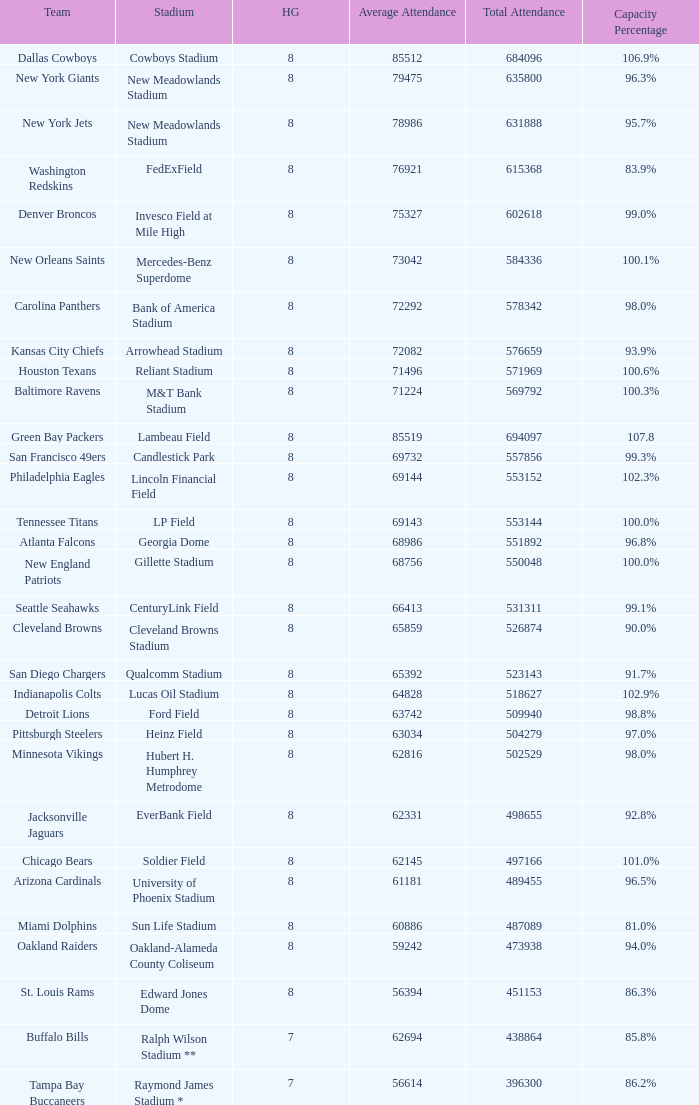Give me the full table as a dictionary. {'header': ['Team', 'Stadium', 'HG', 'Average Attendance', 'Total Attendance', 'Capacity Percentage'], 'rows': [['Dallas Cowboys', 'Cowboys Stadium', '8', '85512', '684096', '106.9%'], ['New York Giants', 'New Meadowlands Stadium', '8', '79475', '635800', '96.3%'], ['New York Jets', 'New Meadowlands Stadium', '8', '78986', '631888', '95.7%'], ['Washington Redskins', 'FedExField', '8', '76921', '615368', '83.9%'], ['Denver Broncos', 'Invesco Field at Mile High', '8', '75327', '602618', '99.0%'], ['New Orleans Saints', 'Mercedes-Benz Superdome', '8', '73042', '584336', '100.1%'], ['Carolina Panthers', 'Bank of America Stadium', '8', '72292', '578342', '98.0%'], ['Kansas City Chiefs', 'Arrowhead Stadium', '8', '72082', '576659', '93.9%'], ['Houston Texans', 'Reliant Stadium', '8', '71496', '571969', '100.6%'], ['Baltimore Ravens', 'M&T Bank Stadium', '8', '71224', '569792', '100.3%'], ['Green Bay Packers', 'Lambeau Field', '8', '85519', '694097', '107.8'], ['San Francisco 49ers', 'Candlestick Park', '8', '69732', '557856', '99.3%'], ['Philadelphia Eagles', 'Lincoln Financial Field', '8', '69144', '553152', '102.3%'], ['Tennessee Titans', 'LP Field', '8', '69143', '553144', '100.0%'], ['Atlanta Falcons', 'Georgia Dome', '8', '68986', '551892', '96.8%'], ['New England Patriots', 'Gillette Stadium', '8', '68756', '550048', '100.0%'], ['Seattle Seahawks', 'CenturyLink Field', '8', '66413', '531311', '99.1%'], ['Cleveland Browns', 'Cleveland Browns Stadium', '8', '65859', '526874', '90.0%'], ['San Diego Chargers', 'Qualcomm Stadium', '8', '65392', '523143', '91.7%'], ['Indianapolis Colts', 'Lucas Oil Stadium', '8', '64828', '518627', '102.9%'], ['Detroit Lions', 'Ford Field', '8', '63742', '509940', '98.8%'], ['Pittsburgh Steelers', 'Heinz Field', '8', '63034', '504279', '97.0%'], ['Minnesota Vikings', 'Hubert H. Humphrey Metrodome', '8', '62816', '502529', '98.0%'], ['Jacksonville Jaguars', 'EverBank Field', '8', '62331', '498655', '92.8%'], ['Chicago Bears', 'Soldier Field', '8', '62145', '497166', '101.0%'], ['Arizona Cardinals', 'University of Phoenix Stadium', '8', '61181', '489455', '96.5%'], ['Miami Dolphins', 'Sun Life Stadium', '8', '60886', '487089', '81.0%'], ['Oakland Raiders', 'Oakland-Alameda County Coliseum', '8', '59242', '473938', '94.0%'], ['St. Louis Rams', 'Edward Jones Dome', '8', '56394', '451153', '86.3%'], ['Buffalo Bills', 'Ralph Wilson Stadium **', '7', '62694', '438864', '85.8%'], ['Tampa Bay Buccaneers', 'Raymond James Stadium *', '7', '56614', '396300', '86.2%']]} What is the number listed in home games when the team is Seattle Seahawks? 8.0. 